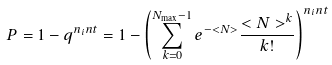<formula> <loc_0><loc_0><loc_500><loc_500>P = 1 - q ^ { n _ { i } n t } = 1 - \left ( \sum _ { k = 0 } ^ { N _ { \max } - 1 } e ^ { - < N > } \frac { < N > ^ { k } } { k ! } \right ) ^ { n _ { i } n t }</formula> 